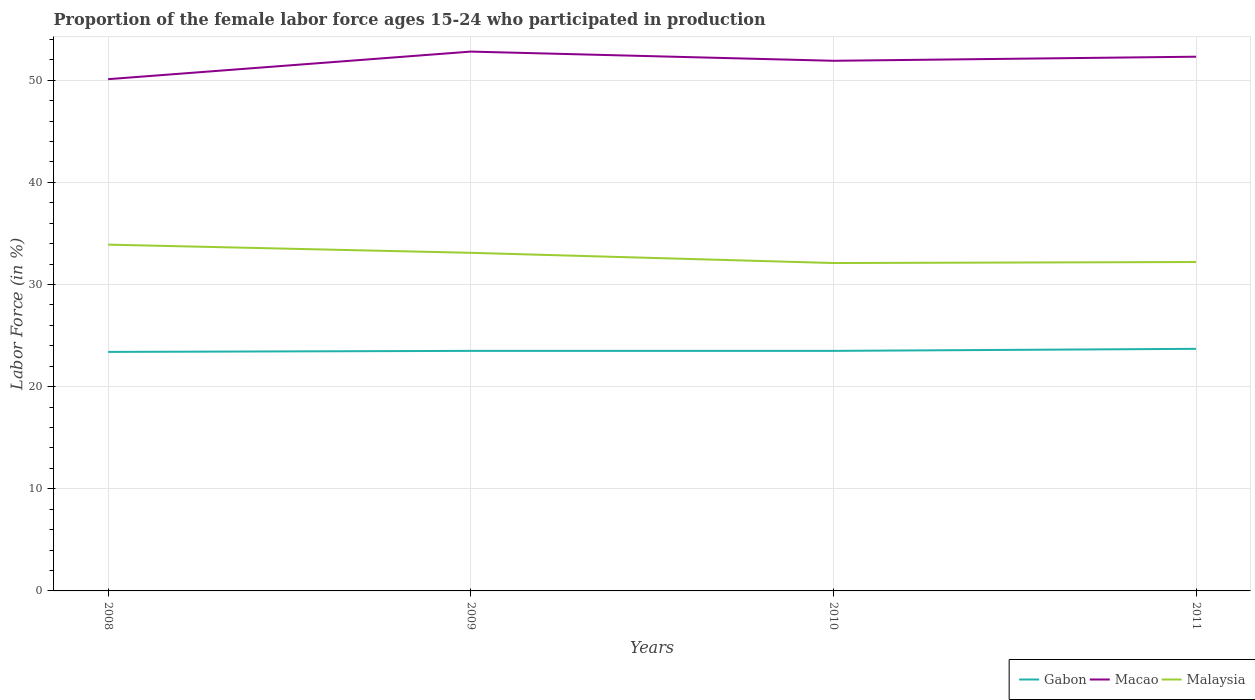Does the line corresponding to Macao intersect with the line corresponding to Malaysia?
Your answer should be compact. No. Across all years, what is the maximum proportion of the female labor force who participated in production in Gabon?
Provide a succinct answer. 23.4. In which year was the proportion of the female labor force who participated in production in Gabon maximum?
Offer a terse response. 2008. What is the difference between the highest and the second highest proportion of the female labor force who participated in production in Gabon?
Give a very brief answer. 0.3. Is the proportion of the female labor force who participated in production in Gabon strictly greater than the proportion of the female labor force who participated in production in Macao over the years?
Ensure brevity in your answer.  Yes. How many lines are there?
Your answer should be very brief. 3. What is the difference between two consecutive major ticks on the Y-axis?
Provide a succinct answer. 10. Are the values on the major ticks of Y-axis written in scientific E-notation?
Offer a terse response. No. Does the graph contain grids?
Keep it short and to the point. Yes. Where does the legend appear in the graph?
Offer a very short reply. Bottom right. How many legend labels are there?
Provide a short and direct response. 3. How are the legend labels stacked?
Keep it short and to the point. Horizontal. What is the title of the graph?
Ensure brevity in your answer.  Proportion of the female labor force ages 15-24 who participated in production. What is the label or title of the X-axis?
Provide a short and direct response. Years. What is the Labor Force (in %) in Gabon in 2008?
Offer a terse response. 23.4. What is the Labor Force (in %) of Macao in 2008?
Provide a succinct answer. 50.1. What is the Labor Force (in %) of Malaysia in 2008?
Provide a short and direct response. 33.9. What is the Labor Force (in %) of Gabon in 2009?
Make the answer very short. 23.5. What is the Labor Force (in %) of Macao in 2009?
Provide a succinct answer. 52.8. What is the Labor Force (in %) of Malaysia in 2009?
Give a very brief answer. 33.1. What is the Labor Force (in %) in Gabon in 2010?
Provide a succinct answer. 23.5. What is the Labor Force (in %) of Macao in 2010?
Keep it short and to the point. 51.9. What is the Labor Force (in %) in Malaysia in 2010?
Offer a very short reply. 32.1. What is the Labor Force (in %) of Gabon in 2011?
Offer a very short reply. 23.7. What is the Labor Force (in %) of Macao in 2011?
Give a very brief answer. 52.3. What is the Labor Force (in %) in Malaysia in 2011?
Provide a succinct answer. 32.2. Across all years, what is the maximum Labor Force (in %) in Gabon?
Your answer should be very brief. 23.7. Across all years, what is the maximum Labor Force (in %) of Macao?
Offer a very short reply. 52.8. Across all years, what is the maximum Labor Force (in %) in Malaysia?
Ensure brevity in your answer.  33.9. Across all years, what is the minimum Labor Force (in %) of Gabon?
Your answer should be very brief. 23.4. Across all years, what is the minimum Labor Force (in %) of Macao?
Give a very brief answer. 50.1. Across all years, what is the minimum Labor Force (in %) of Malaysia?
Your response must be concise. 32.1. What is the total Labor Force (in %) of Gabon in the graph?
Your answer should be compact. 94.1. What is the total Labor Force (in %) of Macao in the graph?
Make the answer very short. 207.1. What is the total Labor Force (in %) of Malaysia in the graph?
Ensure brevity in your answer.  131.3. What is the difference between the Labor Force (in %) in Gabon in 2008 and that in 2009?
Your answer should be very brief. -0.1. What is the difference between the Labor Force (in %) in Malaysia in 2008 and that in 2009?
Ensure brevity in your answer.  0.8. What is the difference between the Labor Force (in %) in Macao in 2008 and that in 2010?
Your answer should be very brief. -1.8. What is the difference between the Labor Force (in %) in Gabon in 2008 and that in 2011?
Offer a terse response. -0.3. What is the difference between the Labor Force (in %) of Macao in 2008 and that in 2011?
Make the answer very short. -2.2. What is the difference between the Labor Force (in %) of Macao in 2009 and that in 2010?
Ensure brevity in your answer.  0.9. What is the difference between the Labor Force (in %) in Gabon in 2009 and that in 2011?
Your answer should be compact. -0.2. What is the difference between the Labor Force (in %) of Macao in 2009 and that in 2011?
Provide a short and direct response. 0.5. What is the difference between the Labor Force (in %) of Malaysia in 2009 and that in 2011?
Ensure brevity in your answer.  0.9. What is the difference between the Labor Force (in %) in Gabon in 2010 and that in 2011?
Keep it short and to the point. -0.2. What is the difference between the Labor Force (in %) of Malaysia in 2010 and that in 2011?
Your response must be concise. -0.1. What is the difference between the Labor Force (in %) in Gabon in 2008 and the Labor Force (in %) in Macao in 2009?
Make the answer very short. -29.4. What is the difference between the Labor Force (in %) of Macao in 2008 and the Labor Force (in %) of Malaysia in 2009?
Keep it short and to the point. 17. What is the difference between the Labor Force (in %) in Gabon in 2008 and the Labor Force (in %) in Macao in 2010?
Your answer should be very brief. -28.5. What is the difference between the Labor Force (in %) of Gabon in 2008 and the Labor Force (in %) of Malaysia in 2010?
Your answer should be very brief. -8.7. What is the difference between the Labor Force (in %) of Gabon in 2008 and the Labor Force (in %) of Macao in 2011?
Keep it short and to the point. -28.9. What is the difference between the Labor Force (in %) of Macao in 2008 and the Labor Force (in %) of Malaysia in 2011?
Provide a succinct answer. 17.9. What is the difference between the Labor Force (in %) in Gabon in 2009 and the Labor Force (in %) in Macao in 2010?
Offer a very short reply. -28.4. What is the difference between the Labor Force (in %) in Gabon in 2009 and the Labor Force (in %) in Malaysia in 2010?
Ensure brevity in your answer.  -8.6. What is the difference between the Labor Force (in %) in Macao in 2009 and the Labor Force (in %) in Malaysia in 2010?
Provide a short and direct response. 20.7. What is the difference between the Labor Force (in %) in Gabon in 2009 and the Labor Force (in %) in Macao in 2011?
Your response must be concise. -28.8. What is the difference between the Labor Force (in %) in Gabon in 2009 and the Labor Force (in %) in Malaysia in 2011?
Keep it short and to the point. -8.7. What is the difference between the Labor Force (in %) in Macao in 2009 and the Labor Force (in %) in Malaysia in 2011?
Offer a terse response. 20.6. What is the difference between the Labor Force (in %) of Gabon in 2010 and the Labor Force (in %) of Macao in 2011?
Provide a succinct answer. -28.8. What is the average Labor Force (in %) of Gabon per year?
Your response must be concise. 23.52. What is the average Labor Force (in %) of Macao per year?
Offer a terse response. 51.77. What is the average Labor Force (in %) in Malaysia per year?
Provide a short and direct response. 32.83. In the year 2008, what is the difference between the Labor Force (in %) of Gabon and Labor Force (in %) of Macao?
Offer a terse response. -26.7. In the year 2008, what is the difference between the Labor Force (in %) of Gabon and Labor Force (in %) of Malaysia?
Your answer should be compact. -10.5. In the year 2009, what is the difference between the Labor Force (in %) of Gabon and Labor Force (in %) of Macao?
Provide a short and direct response. -29.3. In the year 2009, what is the difference between the Labor Force (in %) of Macao and Labor Force (in %) of Malaysia?
Keep it short and to the point. 19.7. In the year 2010, what is the difference between the Labor Force (in %) of Gabon and Labor Force (in %) of Macao?
Provide a short and direct response. -28.4. In the year 2010, what is the difference between the Labor Force (in %) of Macao and Labor Force (in %) of Malaysia?
Make the answer very short. 19.8. In the year 2011, what is the difference between the Labor Force (in %) in Gabon and Labor Force (in %) in Macao?
Make the answer very short. -28.6. In the year 2011, what is the difference between the Labor Force (in %) of Gabon and Labor Force (in %) of Malaysia?
Your response must be concise. -8.5. In the year 2011, what is the difference between the Labor Force (in %) in Macao and Labor Force (in %) in Malaysia?
Your answer should be very brief. 20.1. What is the ratio of the Labor Force (in %) of Gabon in 2008 to that in 2009?
Provide a succinct answer. 1. What is the ratio of the Labor Force (in %) of Macao in 2008 to that in 2009?
Provide a short and direct response. 0.95. What is the ratio of the Labor Force (in %) in Malaysia in 2008 to that in 2009?
Offer a very short reply. 1.02. What is the ratio of the Labor Force (in %) of Macao in 2008 to that in 2010?
Provide a succinct answer. 0.97. What is the ratio of the Labor Force (in %) in Malaysia in 2008 to that in 2010?
Keep it short and to the point. 1.06. What is the ratio of the Labor Force (in %) of Gabon in 2008 to that in 2011?
Offer a very short reply. 0.99. What is the ratio of the Labor Force (in %) in Macao in 2008 to that in 2011?
Your answer should be compact. 0.96. What is the ratio of the Labor Force (in %) in Malaysia in 2008 to that in 2011?
Offer a terse response. 1.05. What is the ratio of the Labor Force (in %) of Gabon in 2009 to that in 2010?
Ensure brevity in your answer.  1. What is the ratio of the Labor Force (in %) of Macao in 2009 to that in 2010?
Your answer should be compact. 1.02. What is the ratio of the Labor Force (in %) of Malaysia in 2009 to that in 2010?
Offer a terse response. 1.03. What is the ratio of the Labor Force (in %) of Gabon in 2009 to that in 2011?
Offer a very short reply. 0.99. What is the ratio of the Labor Force (in %) in Macao in 2009 to that in 2011?
Provide a short and direct response. 1.01. What is the ratio of the Labor Force (in %) of Malaysia in 2009 to that in 2011?
Offer a very short reply. 1.03. What is the ratio of the Labor Force (in %) in Gabon in 2010 to that in 2011?
Give a very brief answer. 0.99. What is the ratio of the Labor Force (in %) in Macao in 2010 to that in 2011?
Offer a very short reply. 0.99. What is the difference between the highest and the second highest Labor Force (in %) of Gabon?
Offer a terse response. 0.2. What is the difference between the highest and the second highest Labor Force (in %) in Macao?
Give a very brief answer. 0.5. What is the difference between the highest and the second highest Labor Force (in %) in Malaysia?
Make the answer very short. 0.8. What is the difference between the highest and the lowest Labor Force (in %) of Macao?
Offer a terse response. 2.7. What is the difference between the highest and the lowest Labor Force (in %) in Malaysia?
Your answer should be compact. 1.8. 